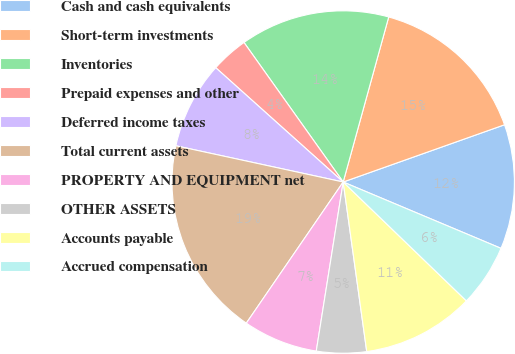Convert chart to OTSL. <chart><loc_0><loc_0><loc_500><loc_500><pie_chart><fcel>Cash and cash equivalents<fcel>Short-term investments<fcel>Inventories<fcel>Prepaid expenses and other<fcel>Deferred income taxes<fcel>Total current assets<fcel>PROPERTY AND EQUIPMENT net<fcel>OTHER ASSETS<fcel>Accounts payable<fcel>Accrued compensation<nl><fcel>11.76%<fcel>15.29%<fcel>14.12%<fcel>3.53%<fcel>8.24%<fcel>18.82%<fcel>7.06%<fcel>4.71%<fcel>10.59%<fcel>5.88%<nl></chart> 